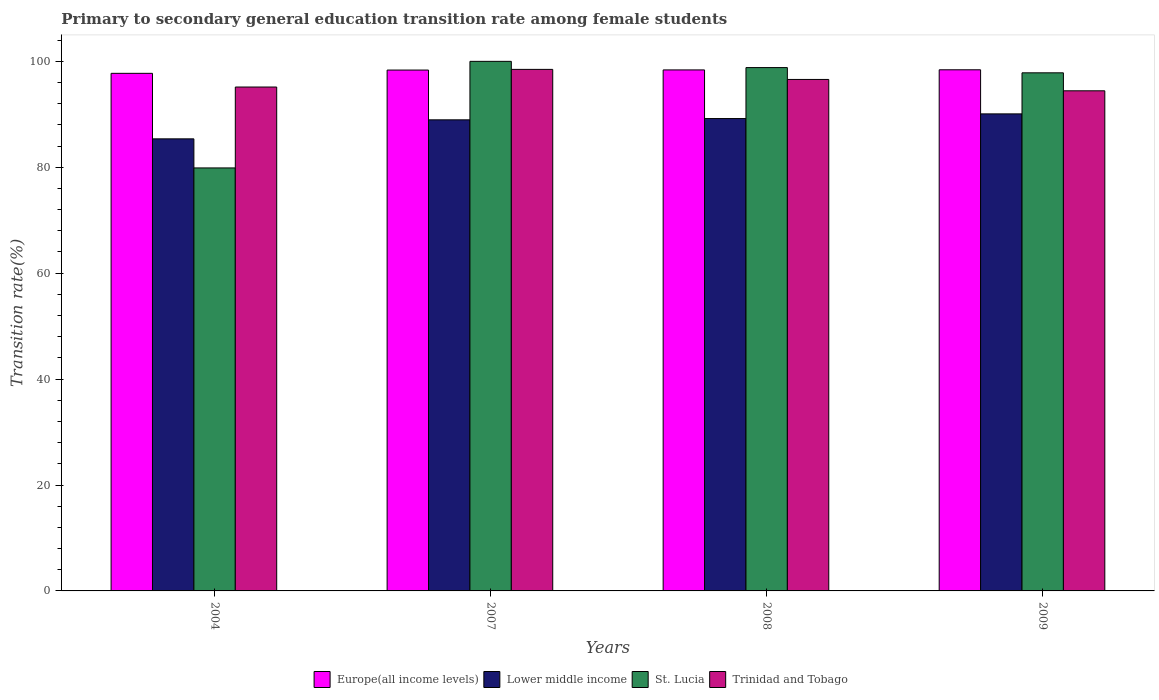How many groups of bars are there?
Your answer should be compact. 4. Are the number of bars on each tick of the X-axis equal?
Your response must be concise. Yes. How many bars are there on the 1st tick from the left?
Your response must be concise. 4. How many bars are there on the 1st tick from the right?
Provide a short and direct response. 4. In how many cases, is the number of bars for a given year not equal to the number of legend labels?
Your answer should be very brief. 0. What is the transition rate in Europe(all income levels) in 2008?
Your response must be concise. 98.38. Across all years, what is the maximum transition rate in Lower middle income?
Give a very brief answer. 90.08. Across all years, what is the minimum transition rate in St. Lucia?
Your answer should be very brief. 79.87. In which year was the transition rate in Trinidad and Tobago minimum?
Your answer should be compact. 2009. What is the total transition rate in Trinidad and Tobago in the graph?
Make the answer very short. 384.66. What is the difference between the transition rate in Trinidad and Tobago in 2004 and that in 2009?
Keep it short and to the point. 0.71. What is the difference between the transition rate in Europe(all income levels) in 2007 and the transition rate in St. Lucia in 2004?
Your answer should be very brief. 18.48. What is the average transition rate in St. Lucia per year?
Ensure brevity in your answer.  94.13. In the year 2004, what is the difference between the transition rate in Europe(all income levels) and transition rate in Trinidad and Tobago?
Make the answer very short. 2.58. In how many years, is the transition rate in Lower middle income greater than 56 %?
Offer a terse response. 4. What is the ratio of the transition rate in Lower middle income in 2008 to that in 2009?
Provide a short and direct response. 0.99. Is the difference between the transition rate in Europe(all income levels) in 2004 and 2007 greater than the difference between the transition rate in Trinidad and Tobago in 2004 and 2007?
Make the answer very short. Yes. What is the difference between the highest and the second highest transition rate in Trinidad and Tobago?
Give a very brief answer. 1.9. What is the difference between the highest and the lowest transition rate in Lower middle income?
Your response must be concise. 4.72. In how many years, is the transition rate in St. Lucia greater than the average transition rate in St. Lucia taken over all years?
Your answer should be very brief. 3. What does the 4th bar from the left in 2004 represents?
Provide a short and direct response. Trinidad and Tobago. What does the 3rd bar from the right in 2008 represents?
Your answer should be very brief. Lower middle income. Is it the case that in every year, the sum of the transition rate in Lower middle income and transition rate in St. Lucia is greater than the transition rate in Europe(all income levels)?
Provide a short and direct response. Yes. How many bars are there?
Keep it short and to the point. 16. Are all the bars in the graph horizontal?
Your answer should be very brief. No. Are the values on the major ticks of Y-axis written in scientific E-notation?
Give a very brief answer. No. Does the graph contain any zero values?
Provide a short and direct response. No. How many legend labels are there?
Make the answer very short. 4. How are the legend labels stacked?
Offer a terse response. Horizontal. What is the title of the graph?
Offer a very short reply. Primary to secondary general education transition rate among female students. Does "France" appear as one of the legend labels in the graph?
Ensure brevity in your answer.  No. What is the label or title of the X-axis?
Give a very brief answer. Years. What is the label or title of the Y-axis?
Give a very brief answer. Transition rate(%). What is the Transition rate(%) of Europe(all income levels) in 2004?
Your response must be concise. 97.74. What is the Transition rate(%) of Lower middle income in 2004?
Your answer should be compact. 85.37. What is the Transition rate(%) of St. Lucia in 2004?
Keep it short and to the point. 79.87. What is the Transition rate(%) of Trinidad and Tobago in 2004?
Give a very brief answer. 95.15. What is the Transition rate(%) in Europe(all income levels) in 2007?
Ensure brevity in your answer.  98.36. What is the Transition rate(%) of Lower middle income in 2007?
Offer a very short reply. 88.96. What is the Transition rate(%) of St. Lucia in 2007?
Your response must be concise. 100. What is the Transition rate(%) in Trinidad and Tobago in 2007?
Your response must be concise. 98.48. What is the Transition rate(%) in Europe(all income levels) in 2008?
Keep it short and to the point. 98.38. What is the Transition rate(%) of Lower middle income in 2008?
Provide a succinct answer. 89.2. What is the Transition rate(%) of St. Lucia in 2008?
Your answer should be compact. 98.82. What is the Transition rate(%) of Trinidad and Tobago in 2008?
Your answer should be compact. 96.58. What is the Transition rate(%) in Europe(all income levels) in 2009?
Your response must be concise. 98.41. What is the Transition rate(%) of Lower middle income in 2009?
Your answer should be very brief. 90.08. What is the Transition rate(%) in St. Lucia in 2009?
Ensure brevity in your answer.  97.83. What is the Transition rate(%) in Trinidad and Tobago in 2009?
Give a very brief answer. 94.44. Across all years, what is the maximum Transition rate(%) of Europe(all income levels)?
Offer a very short reply. 98.41. Across all years, what is the maximum Transition rate(%) in Lower middle income?
Give a very brief answer. 90.08. Across all years, what is the maximum Transition rate(%) in St. Lucia?
Offer a very short reply. 100. Across all years, what is the maximum Transition rate(%) in Trinidad and Tobago?
Provide a short and direct response. 98.48. Across all years, what is the minimum Transition rate(%) of Europe(all income levels)?
Keep it short and to the point. 97.74. Across all years, what is the minimum Transition rate(%) in Lower middle income?
Provide a succinct answer. 85.37. Across all years, what is the minimum Transition rate(%) in St. Lucia?
Make the answer very short. 79.87. Across all years, what is the minimum Transition rate(%) in Trinidad and Tobago?
Your answer should be compact. 94.44. What is the total Transition rate(%) of Europe(all income levels) in the graph?
Ensure brevity in your answer.  392.89. What is the total Transition rate(%) in Lower middle income in the graph?
Provide a short and direct response. 353.6. What is the total Transition rate(%) of St. Lucia in the graph?
Your answer should be compact. 376.53. What is the total Transition rate(%) of Trinidad and Tobago in the graph?
Your response must be concise. 384.66. What is the difference between the Transition rate(%) of Europe(all income levels) in 2004 and that in 2007?
Make the answer very short. -0.62. What is the difference between the Transition rate(%) of Lower middle income in 2004 and that in 2007?
Your answer should be very brief. -3.59. What is the difference between the Transition rate(%) in St. Lucia in 2004 and that in 2007?
Provide a succinct answer. -20.13. What is the difference between the Transition rate(%) of Trinidad and Tobago in 2004 and that in 2007?
Make the answer very short. -3.33. What is the difference between the Transition rate(%) of Europe(all income levels) in 2004 and that in 2008?
Keep it short and to the point. -0.65. What is the difference between the Transition rate(%) of Lower middle income in 2004 and that in 2008?
Provide a succinct answer. -3.83. What is the difference between the Transition rate(%) of St. Lucia in 2004 and that in 2008?
Provide a short and direct response. -18.95. What is the difference between the Transition rate(%) of Trinidad and Tobago in 2004 and that in 2008?
Your answer should be very brief. -1.43. What is the difference between the Transition rate(%) in Europe(all income levels) in 2004 and that in 2009?
Offer a terse response. -0.67. What is the difference between the Transition rate(%) in Lower middle income in 2004 and that in 2009?
Ensure brevity in your answer.  -4.72. What is the difference between the Transition rate(%) of St. Lucia in 2004 and that in 2009?
Give a very brief answer. -17.96. What is the difference between the Transition rate(%) in Trinidad and Tobago in 2004 and that in 2009?
Provide a short and direct response. 0.71. What is the difference between the Transition rate(%) in Europe(all income levels) in 2007 and that in 2008?
Offer a very short reply. -0.03. What is the difference between the Transition rate(%) of Lower middle income in 2007 and that in 2008?
Ensure brevity in your answer.  -0.24. What is the difference between the Transition rate(%) in St. Lucia in 2007 and that in 2008?
Offer a terse response. 1.18. What is the difference between the Transition rate(%) in Trinidad and Tobago in 2007 and that in 2008?
Offer a terse response. 1.9. What is the difference between the Transition rate(%) of Europe(all income levels) in 2007 and that in 2009?
Give a very brief answer. -0.05. What is the difference between the Transition rate(%) of Lower middle income in 2007 and that in 2009?
Your answer should be compact. -1.13. What is the difference between the Transition rate(%) of St. Lucia in 2007 and that in 2009?
Provide a short and direct response. 2.17. What is the difference between the Transition rate(%) in Trinidad and Tobago in 2007 and that in 2009?
Offer a very short reply. 4.05. What is the difference between the Transition rate(%) of Europe(all income levels) in 2008 and that in 2009?
Ensure brevity in your answer.  -0.02. What is the difference between the Transition rate(%) of Lower middle income in 2008 and that in 2009?
Give a very brief answer. -0.88. What is the difference between the Transition rate(%) of St. Lucia in 2008 and that in 2009?
Ensure brevity in your answer.  0.99. What is the difference between the Transition rate(%) in Trinidad and Tobago in 2008 and that in 2009?
Offer a terse response. 2.15. What is the difference between the Transition rate(%) in Europe(all income levels) in 2004 and the Transition rate(%) in Lower middle income in 2007?
Ensure brevity in your answer.  8.78. What is the difference between the Transition rate(%) in Europe(all income levels) in 2004 and the Transition rate(%) in St. Lucia in 2007?
Your answer should be compact. -2.26. What is the difference between the Transition rate(%) of Europe(all income levels) in 2004 and the Transition rate(%) of Trinidad and Tobago in 2007?
Your answer should be compact. -0.75. What is the difference between the Transition rate(%) in Lower middle income in 2004 and the Transition rate(%) in St. Lucia in 2007?
Give a very brief answer. -14.63. What is the difference between the Transition rate(%) of Lower middle income in 2004 and the Transition rate(%) of Trinidad and Tobago in 2007?
Your answer should be very brief. -13.12. What is the difference between the Transition rate(%) in St. Lucia in 2004 and the Transition rate(%) in Trinidad and Tobago in 2007?
Provide a short and direct response. -18.61. What is the difference between the Transition rate(%) in Europe(all income levels) in 2004 and the Transition rate(%) in Lower middle income in 2008?
Ensure brevity in your answer.  8.54. What is the difference between the Transition rate(%) of Europe(all income levels) in 2004 and the Transition rate(%) of St. Lucia in 2008?
Your answer should be compact. -1.08. What is the difference between the Transition rate(%) of Europe(all income levels) in 2004 and the Transition rate(%) of Trinidad and Tobago in 2008?
Keep it short and to the point. 1.15. What is the difference between the Transition rate(%) of Lower middle income in 2004 and the Transition rate(%) of St. Lucia in 2008?
Offer a terse response. -13.46. What is the difference between the Transition rate(%) of Lower middle income in 2004 and the Transition rate(%) of Trinidad and Tobago in 2008?
Give a very brief answer. -11.22. What is the difference between the Transition rate(%) of St. Lucia in 2004 and the Transition rate(%) of Trinidad and Tobago in 2008?
Make the answer very short. -16.71. What is the difference between the Transition rate(%) in Europe(all income levels) in 2004 and the Transition rate(%) in Lower middle income in 2009?
Your answer should be very brief. 7.66. What is the difference between the Transition rate(%) of Europe(all income levels) in 2004 and the Transition rate(%) of St. Lucia in 2009?
Give a very brief answer. -0.1. What is the difference between the Transition rate(%) of Europe(all income levels) in 2004 and the Transition rate(%) of Trinidad and Tobago in 2009?
Provide a short and direct response. 3.3. What is the difference between the Transition rate(%) of Lower middle income in 2004 and the Transition rate(%) of St. Lucia in 2009?
Your answer should be very brief. -12.47. What is the difference between the Transition rate(%) in Lower middle income in 2004 and the Transition rate(%) in Trinidad and Tobago in 2009?
Offer a very short reply. -9.07. What is the difference between the Transition rate(%) of St. Lucia in 2004 and the Transition rate(%) of Trinidad and Tobago in 2009?
Ensure brevity in your answer.  -14.56. What is the difference between the Transition rate(%) of Europe(all income levels) in 2007 and the Transition rate(%) of Lower middle income in 2008?
Your answer should be very brief. 9.16. What is the difference between the Transition rate(%) of Europe(all income levels) in 2007 and the Transition rate(%) of St. Lucia in 2008?
Ensure brevity in your answer.  -0.47. What is the difference between the Transition rate(%) in Europe(all income levels) in 2007 and the Transition rate(%) in Trinidad and Tobago in 2008?
Give a very brief answer. 1.77. What is the difference between the Transition rate(%) of Lower middle income in 2007 and the Transition rate(%) of St. Lucia in 2008?
Keep it short and to the point. -9.87. What is the difference between the Transition rate(%) in Lower middle income in 2007 and the Transition rate(%) in Trinidad and Tobago in 2008?
Give a very brief answer. -7.63. What is the difference between the Transition rate(%) of St. Lucia in 2007 and the Transition rate(%) of Trinidad and Tobago in 2008?
Your response must be concise. 3.42. What is the difference between the Transition rate(%) in Europe(all income levels) in 2007 and the Transition rate(%) in Lower middle income in 2009?
Keep it short and to the point. 8.28. What is the difference between the Transition rate(%) of Europe(all income levels) in 2007 and the Transition rate(%) of St. Lucia in 2009?
Your response must be concise. 0.52. What is the difference between the Transition rate(%) of Europe(all income levels) in 2007 and the Transition rate(%) of Trinidad and Tobago in 2009?
Give a very brief answer. 3.92. What is the difference between the Transition rate(%) in Lower middle income in 2007 and the Transition rate(%) in St. Lucia in 2009?
Provide a short and direct response. -8.88. What is the difference between the Transition rate(%) in Lower middle income in 2007 and the Transition rate(%) in Trinidad and Tobago in 2009?
Your answer should be compact. -5.48. What is the difference between the Transition rate(%) of St. Lucia in 2007 and the Transition rate(%) of Trinidad and Tobago in 2009?
Ensure brevity in your answer.  5.56. What is the difference between the Transition rate(%) of Europe(all income levels) in 2008 and the Transition rate(%) of Lower middle income in 2009?
Your answer should be very brief. 8.3. What is the difference between the Transition rate(%) of Europe(all income levels) in 2008 and the Transition rate(%) of St. Lucia in 2009?
Ensure brevity in your answer.  0.55. What is the difference between the Transition rate(%) in Europe(all income levels) in 2008 and the Transition rate(%) in Trinidad and Tobago in 2009?
Provide a succinct answer. 3.94. What is the difference between the Transition rate(%) of Lower middle income in 2008 and the Transition rate(%) of St. Lucia in 2009?
Offer a terse response. -8.64. What is the difference between the Transition rate(%) in Lower middle income in 2008 and the Transition rate(%) in Trinidad and Tobago in 2009?
Make the answer very short. -5.24. What is the difference between the Transition rate(%) of St. Lucia in 2008 and the Transition rate(%) of Trinidad and Tobago in 2009?
Your response must be concise. 4.38. What is the average Transition rate(%) of Europe(all income levels) per year?
Provide a short and direct response. 98.22. What is the average Transition rate(%) in Lower middle income per year?
Make the answer very short. 88.4. What is the average Transition rate(%) in St. Lucia per year?
Provide a short and direct response. 94.13. What is the average Transition rate(%) in Trinidad and Tobago per year?
Give a very brief answer. 96.17. In the year 2004, what is the difference between the Transition rate(%) in Europe(all income levels) and Transition rate(%) in Lower middle income?
Make the answer very short. 12.37. In the year 2004, what is the difference between the Transition rate(%) in Europe(all income levels) and Transition rate(%) in St. Lucia?
Make the answer very short. 17.86. In the year 2004, what is the difference between the Transition rate(%) of Europe(all income levels) and Transition rate(%) of Trinidad and Tobago?
Offer a very short reply. 2.58. In the year 2004, what is the difference between the Transition rate(%) of Lower middle income and Transition rate(%) of St. Lucia?
Keep it short and to the point. 5.49. In the year 2004, what is the difference between the Transition rate(%) of Lower middle income and Transition rate(%) of Trinidad and Tobago?
Provide a short and direct response. -9.79. In the year 2004, what is the difference between the Transition rate(%) in St. Lucia and Transition rate(%) in Trinidad and Tobago?
Your answer should be very brief. -15.28. In the year 2007, what is the difference between the Transition rate(%) in Europe(all income levels) and Transition rate(%) in Lower middle income?
Provide a short and direct response. 9.4. In the year 2007, what is the difference between the Transition rate(%) in Europe(all income levels) and Transition rate(%) in St. Lucia?
Provide a succinct answer. -1.64. In the year 2007, what is the difference between the Transition rate(%) of Europe(all income levels) and Transition rate(%) of Trinidad and Tobago?
Ensure brevity in your answer.  -0.13. In the year 2007, what is the difference between the Transition rate(%) in Lower middle income and Transition rate(%) in St. Lucia?
Provide a succinct answer. -11.04. In the year 2007, what is the difference between the Transition rate(%) in Lower middle income and Transition rate(%) in Trinidad and Tobago?
Provide a short and direct response. -9.53. In the year 2007, what is the difference between the Transition rate(%) in St. Lucia and Transition rate(%) in Trinidad and Tobago?
Keep it short and to the point. 1.52. In the year 2008, what is the difference between the Transition rate(%) in Europe(all income levels) and Transition rate(%) in Lower middle income?
Provide a succinct answer. 9.19. In the year 2008, what is the difference between the Transition rate(%) in Europe(all income levels) and Transition rate(%) in St. Lucia?
Your answer should be very brief. -0.44. In the year 2008, what is the difference between the Transition rate(%) of Europe(all income levels) and Transition rate(%) of Trinidad and Tobago?
Offer a very short reply. 1.8. In the year 2008, what is the difference between the Transition rate(%) in Lower middle income and Transition rate(%) in St. Lucia?
Ensure brevity in your answer.  -9.63. In the year 2008, what is the difference between the Transition rate(%) in Lower middle income and Transition rate(%) in Trinidad and Tobago?
Keep it short and to the point. -7.39. In the year 2008, what is the difference between the Transition rate(%) in St. Lucia and Transition rate(%) in Trinidad and Tobago?
Your answer should be very brief. 2.24. In the year 2009, what is the difference between the Transition rate(%) in Europe(all income levels) and Transition rate(%) in Lower middle income?
Your answer should be compact. 8.33. In the year 2009, what is the difference between the Transition rate(%) of Europe(all income levels) and Transition rate(%) of St. Lucia?
Provide a short and direct response. 0.57. In the year 2009, what is the difference between the Transition rate(%) of Europe(all income levels) and Transition rate(%) of Trinidad and Tobago?
Provide a succinct answer. 3.97. In the year 2009, what is the difference between the Transition rate(%) in Lower middle income and Transition rate(%) in St. Lucia?
Your answer should be very brief. -7.75. In the year 2009, what is the difference between the Transition rate(%) of Lower middle income and Transition rate(%) of Trinidad and Tobago?
Your response must be concise. -4.36. In the year 2009, what is the difference between the Transition rate(%) in St. Lucia and Transition rate(%) in Trinidad and Tobago?
Offer a terse response. 3.39. What is the ratio of the Transition rate(%) in Lower middle income in 2004 to that in 2007?
Make the answer very short. 0.96. What is the ratio of the Transition rate(%) in St. Lucia in 2004 to that in 2007?
Offer a terse response. 0.8. What is the ratio of the Transition rate(%) of Trinidad and Tobago in 2004 to that in 2007?
Provide a succinct answer. 0.97. What is the ratio of the Transition rate(%) of Lower middle income in 2004 to that in 2008?
Your answer should be very brief. 0.96. What is the ratio of the Transition rate(%) in St. Lucia in 2004 to that in 2008?
Make the answer very short. 0.81. What is the ratio of the Transition rate(%) in Trinidad and Tobago in 2004 to that in 2008?
Ensure brevity in your answer.  0.99. What is the ratio of the Transition rate(%) of Europe(all income levels) in 2004 to that in 2009?
Provide a succinct answer. 0.99. What is the ratio of the Transition rate(%) of Lower middle income in 2004 to that in 2009?
Provide a short and direct response. 0.95. What is the ratio of the Transition rate(%) of St. Lucia in 2004 to that in 2009?
Offer a very short reply. 0.82. What is the ratio of the Transition rate(%) in Trinidad and Tobago in 2004 to that in 2009?
Your response must be concise. 1.01. What is the ratio of the Transition rate(%) of Lower middle income in 2007 to that in 2008?
Provide a short and direct response. 1. What is the ratio of the Transition rate(%) in St. Lucia in 2007 to that in 2008?
Keep it short and to the point. 1.01. What is the ratio of the Transition rate(%) in Trinidad and Tobago in 2007 to that in 2008?
Your answer should be very brief. 1.02. What is the ratio of the Transition rate(%) in Europe(all income levels) in 2007 to that in 2009?
Keep it short and to the point. 1. What is the ratio of the Transition rate(%) in Lower middle income in 2007 to that in 2009?
Your response must be concise. 0.99. What is the ratio of the Transition rate(%) of St. Lucia in 2007 to that in 2009?
Your answer should be very brief. 1.02. What is the ratio of the Transition rate(%) in Trinidad and Tobago in 2007 to that in 2009?
Your answer should be compact. 1.04. What is the ratio of the Transition rate(%) in Europe(all income levels) in 2008 to that in 2009?
Your answer should be very brief. 1. What is the ratio of the Transition rate(%) of Lower middle income in 2008 to that in 2009?
Your answer should be very brief. 0.99. What is the ratio of the Transition rate(%) in St. Lucia in 2008 to that in 2009?
Provide a succinct answer. 1.01. What is the ratio of the Transition rate(%) in Trinidad and Tobago in 2008 to that in 2009?
Offer a terse response. 1.02. What is the difference between the highest and the second highest Transition rate(%) of Europe(all income levels)?
Your answer should be very brief. 0.02. What is the difference between the highest and the second highest Transition rate(%) in Lower middle income?
Your answer should be compact. 0.88. What is the difference between the highest and the second highest Transition rate(%) in St. Lucia?
Provide a short and direct response. 1.18. What is the difference between the highest and the second highest Transition rate(%) in Trinidad and Tobago?
Offer a terse response. 1.9. What is the difference between the highest and the lowest Transition rate(%) in Europe(all income levels)?
Provide a short and direct response. 0.67. What is the difference between the highest and the lowest Transition rate(%) in Lower middle income?
Offer a terse response. 4.72. What is the difference between the highest and the lowest Transition rate(%) in St. Lucia?
Give a very brief answer. 20.13. What is the difference between the highest and the lowest Transition rate(%) of Trinidad and Tobago?
Offer a very short reply. 4.05. 